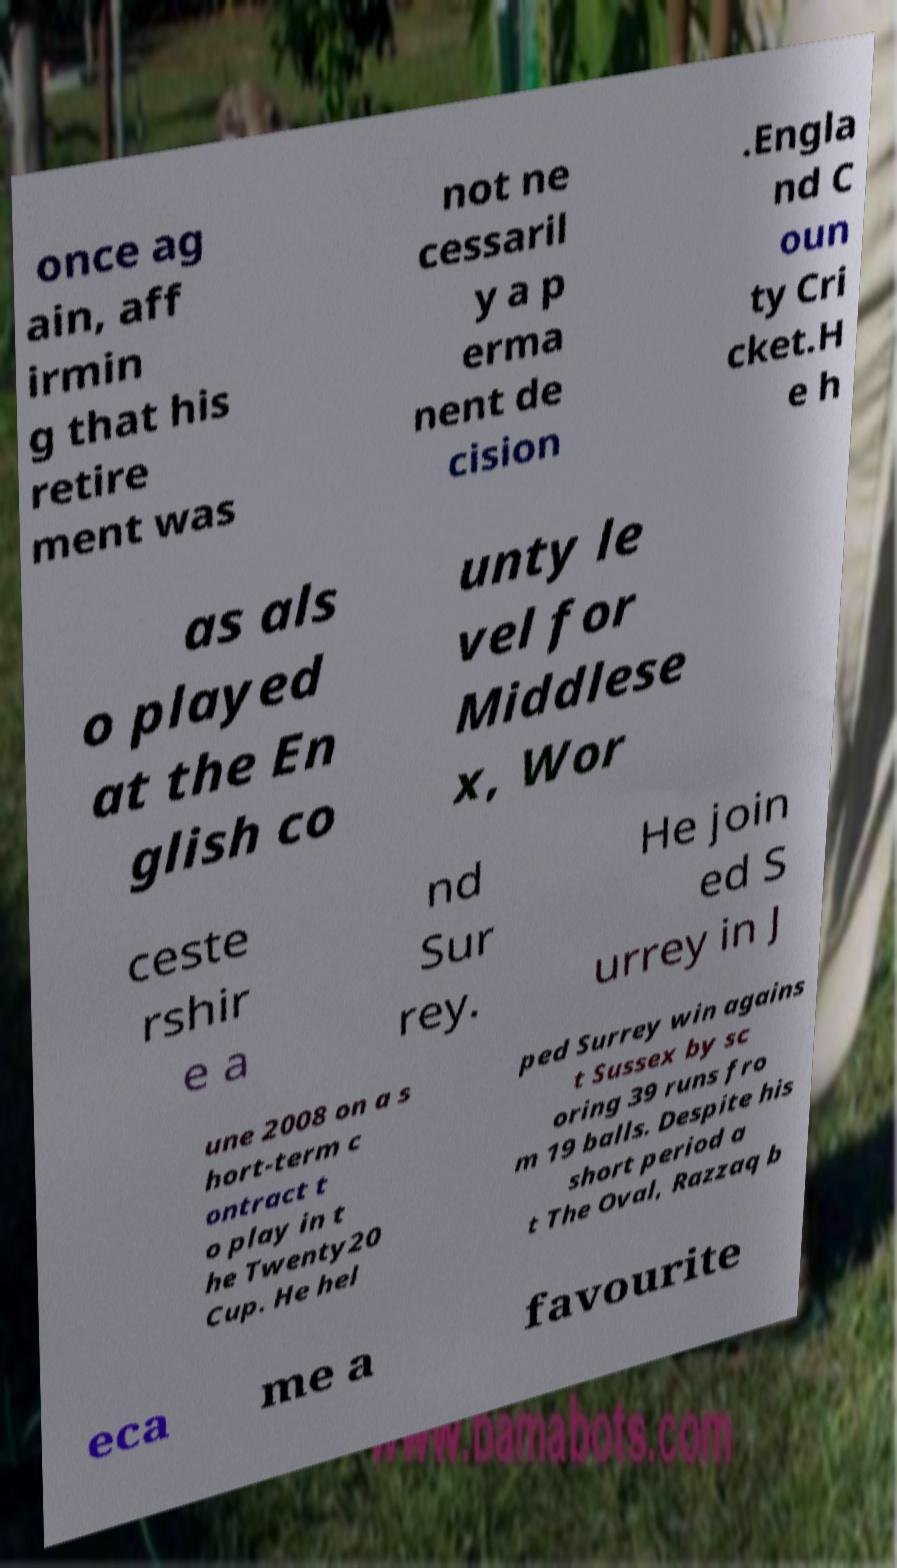Can you accurately transcribe the text from the provided image for me? once ag ain, aff irmin g that his retire ment was not ne cessaril y a p erma nent de cision .Engla nd C oun ty Cri cket.H e h as als o played at the En glish co unty le vel for Middlese x, Wor ceste rshir e a nd Sur rey. He join ed S urrey in J une 2008 on a s hort-term c ontract t o play in t he Twenty20 Cup. He hel ped Surrey win agains t Sussex by sc oring 39 runs fro m 19 balls. Despite his short period a t The Oval, Razzaq b eca me a favourite 